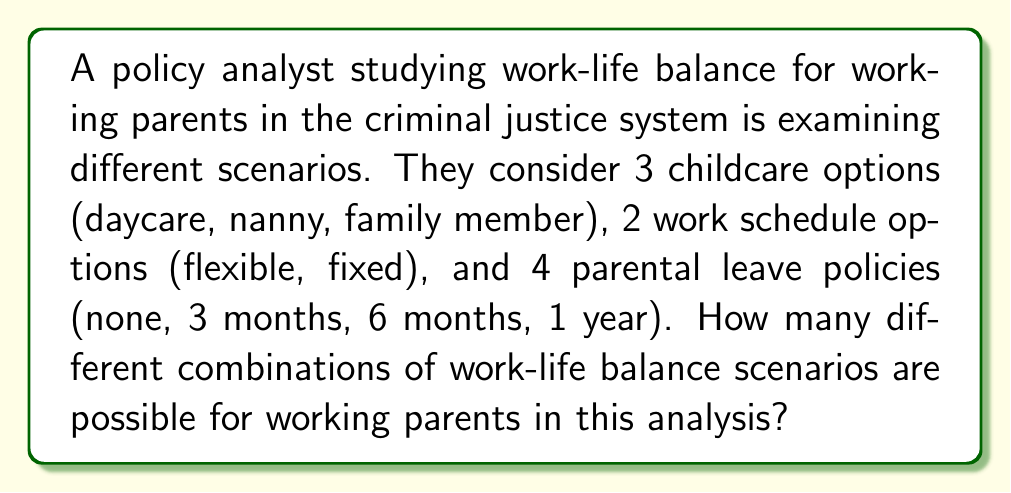Help me with this question. To solve this problem, we'll use the multiplication principle of counting. This principle states that if we have a series of independent choices, the total number of possible outcomes is the product of the number of options for each choice.

Let's break down the given information:
1. Childcare options: 3 choices
2. Work schedule options: 2 choices
3. Parental leave policies: 4 choices

To find the total number of possible combinations, we multiply these numbers together:

$$ \text{Total combinations} = 3 \times 2 \times 4 $$

Calculating:
$$ 3 \times 2 \times 4 = 6 \times 4 = 24 $$

Therefore, there are 24 different possible combinations of work-life balance scenarios for working parents in this analysis.

This approach allows the policy analyst to systematically consider all possible scenarios, which is crucial for developing comprehensive policies that address the diverse needs of working parents in the criminal justice system.
Answer: 24 combinations 